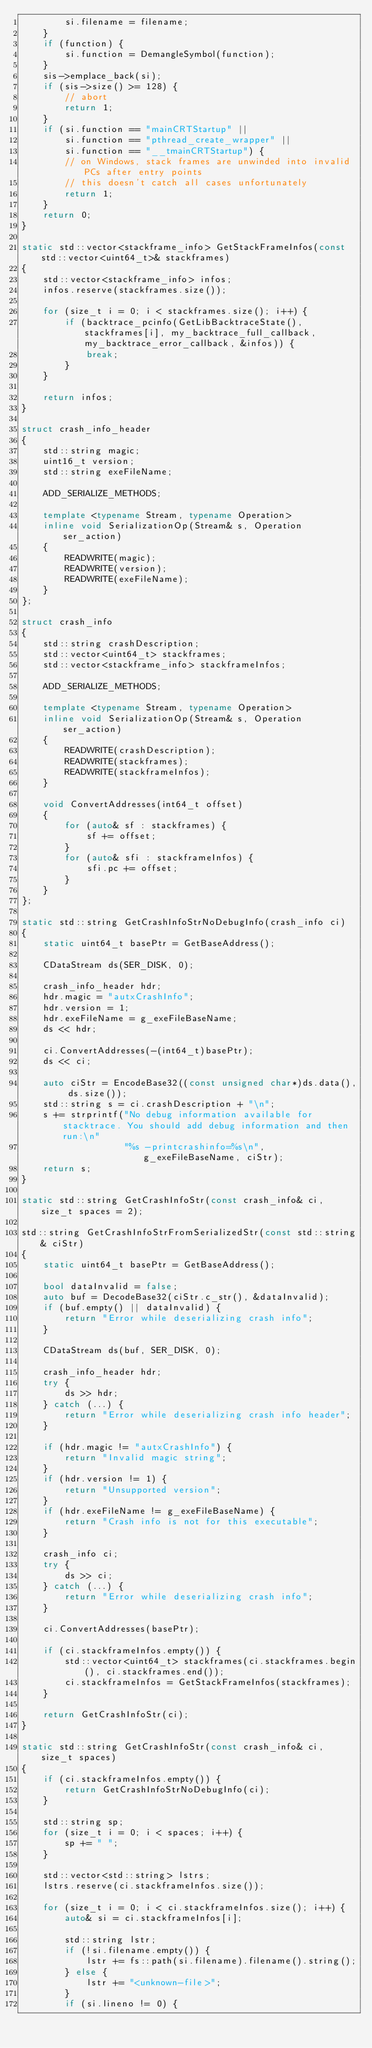Convert code to text. <code><loc_0><loc_0><loc_500><loc_500><_C++_>        si.filename = filename;
    }
    if (function) {
        si.function = DemangleSymbol(function);
    }
    sis->emplace_back(si);
    if (sis->size() >= 128) {
        // abort
        return 1;
    }
    if (si.function == "mainCRTStartup" ||
        si.function == "pthread_create_wrapper" ||
        si.function == "__tmainCRTStartup") {
        // on Windows, stack frames are unwinded into invalid PCs after entry points
        // this doesn't catch all cases unfortunately
        return 1;
    }
    return 0;
}

static std::vector<stackframe_info> GetStackFrameInfos(const std::vector<uint64_t>& stackframes)
{
    std::vector<stackframe_info> infos;
    infos.reserve(stackframes.size());

    for (size_t i = 0; i < stackframes.size(); i++) {
        if (backtrace_pcinfo(GetLibBacktraceState(), stackframes[i], my_backtrace_full_callback, my_backtrace_error_callback, &infos)) {
            break;
        }
    }

    return infos;
}

struct crash_info_header
{
    std::string magic;
    uint16_t version;
    std::string exeFileName;

    ADD_SERIALIZE_METHODS;

    template <typename Stream, typename Operation>
    inline void SerializationOp(Stream& s, Operation ser_action)
    {
        READWRITE(magic);
        READWRITE(version);
        READWRITE(exeFileName);
    }
};

struct crash_info
{
    std::string crashDescription;
    std::vector<uint64_t> stackframes;
    std::vector<stackframe_info> stackframeInfos;

    ADD_SERIALIZE_METHODS;

    template <typename Stream, typename Operation>
    inline void SerializationOp(Stream& s, Operation ser_action)
    {
        READWRITE(crashDescription);
        READWRITE(stackframes);
        READWRITE(stackframeInfos);
    }

    void ConvertAddresses(int64_t offset)
    {
        for (auto& sf : stackframes) {
            sf += offset;
        }
        for (auto& sfi : stackframeInfos) {
            sfi.pc += offset;
        }
    }
};

static std::string GetCrashInfoStrNoDebugInfo(crash_info ci)
{
    static uint64_t basePtr = GetBaseAddress();

    CDataStream ds(SER_DISK, 0);

    crash_info_header hdr;
    hdr.magic = "autxCrashInfo";
    hdr.version = 1;
    hdr.exeFileName = g_exeFileBaseName;
    ds << hdr;

    ci.ConvertAddresses(-(int64_t)basePtr);
    ds << ci;

    auto ciStr = EncodeBase32((const unsigned char*)ds.data(), ds.size());
    std::string s = ci.crashDescription + "\n";
    s += strprintf("No debug information available for stacktrace. You should add debug information and then run:\n"
                   "%s -printcrashinfo=%s\n", g_exeFileBaseName, ciStr);
    return s;
}

static std::string GetCrashInfoStr(const crash_info& ci, size_t spaces = 2);

std::string GetCrashInfoStrFromSerializedStr(const std::string& ciStr)
{
    static uint64_t basePtr = GetBaseAddress();

    bool dataInvalid = false;
    auto buf = DecodeBase32(ciStr.c_str(), &dataInvalid);
    if (buf.empty() || dataInvalid) {
        return "Error while deserializing crash info";
    }

    CDataStream ds(buf, SER_DISK, 0);

    crash_info_header hdr;
    try {
        ds >> hdr;
    } catch (...) {
        return "Error while deserializing crash info header";
    }

    if (hdr.magic != "autxCrashInfo") {
        return "Invalid magic string";
    }
    if (hdr.version != 1) {
        return "Unsupported version";
    }
    if (hdr.exeFileName != g_exeFileBaseName) {
        return "Crash info is not for this executable";
    }

    crash_info ci;
    try {
        ds >> ci;
    } catch (...) {
        return "Error while deserializing crash info";
    }

    ci.ConvertAddresses(basePtr);

    if (ci.stackframeInfos.empty()) {
        std::vector<uint64_t> stackframes(ci.stackframes.begin(), ci.stackframes.end());
        ci.stackframeInfos = GetStackFrameInfos(stackframes);
    }

    return GetCrashInfoStr(ci);
}

static std::string GetCrashInfoStr(const crash_info& ci, size_t spaces)
{
    if (ci.stackframeInfos.empty()) {
        return GetCrashInfoStrNoDebugInfo(ci);
    }

    std::string sp;
    for (size_t i = 0; i < spaces; i++) {
        sp += " ";
    }

    std::vector<std::string> lstrs;
    lstrs.reserve(ci.stackframeInfos.size());

    for (size_t i = 0; i < ci.stackframeInfos.size(); i++) {
        auto& si = ci.stackframeInfos[i];

        std::string lstr;
        if (!si.filename.empty()) {
            lstr += fs::path(si.filename).filename().string();
        } else {
            lstr += "<unknown-file>";
        }
        if (si.lineno != 0) {</code> 